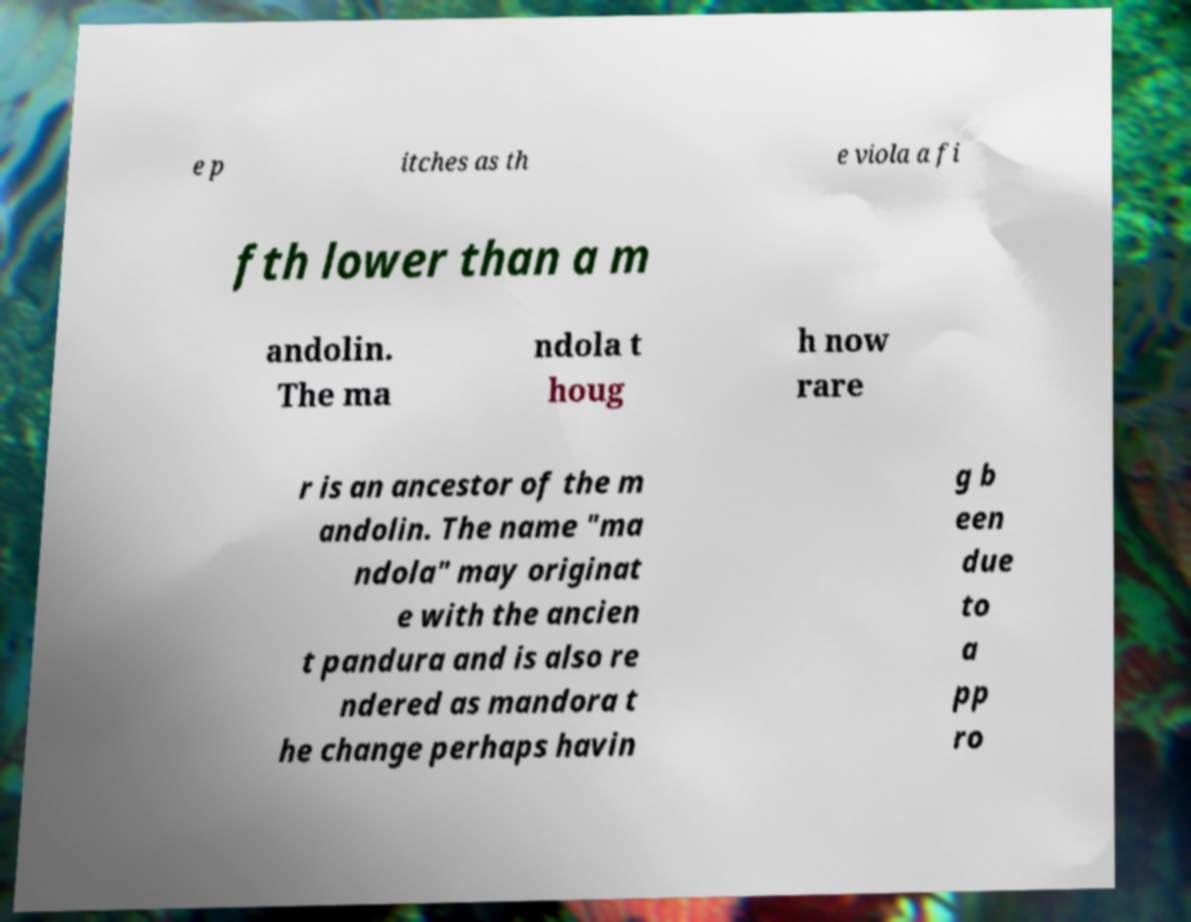Could you extract and type out the text from this image? e p itches as th e viola a fi fth lower than a m andolin. The ma ndola t houg h now rare r is an ancestor of the m andolin. The name "ma ndola" may originat e with the ancien t pandura and is also re ndered as mandora t he change perhaps havin g b een due to a pp ro 